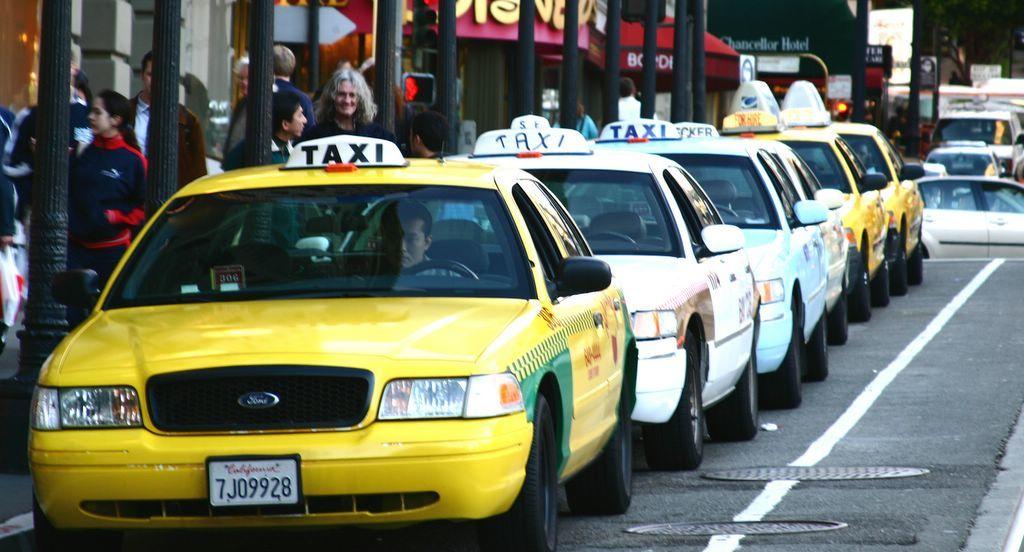What kind of cars are lined up?
Your answer should be compact. Taxi. What state is the front taxi license plate from?
Keep it short and to the point. California. 